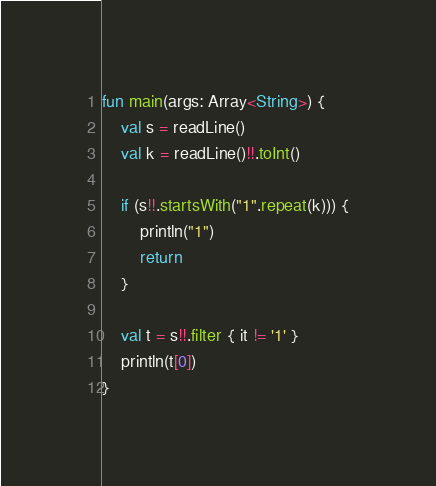<code> <loc_0><loc_0><loc_500><loc_500><_Kotlin_>fun main(args: Array<String>) {
    val s = readLine()
    val k = readLine()!!.toInt()

    if (s!!.startsWith("1".repeat(k))) {
        println("1")
        return
    }
    
    val t = s!!.filter { it != '1' }
    println(t[0])
}
</code> 